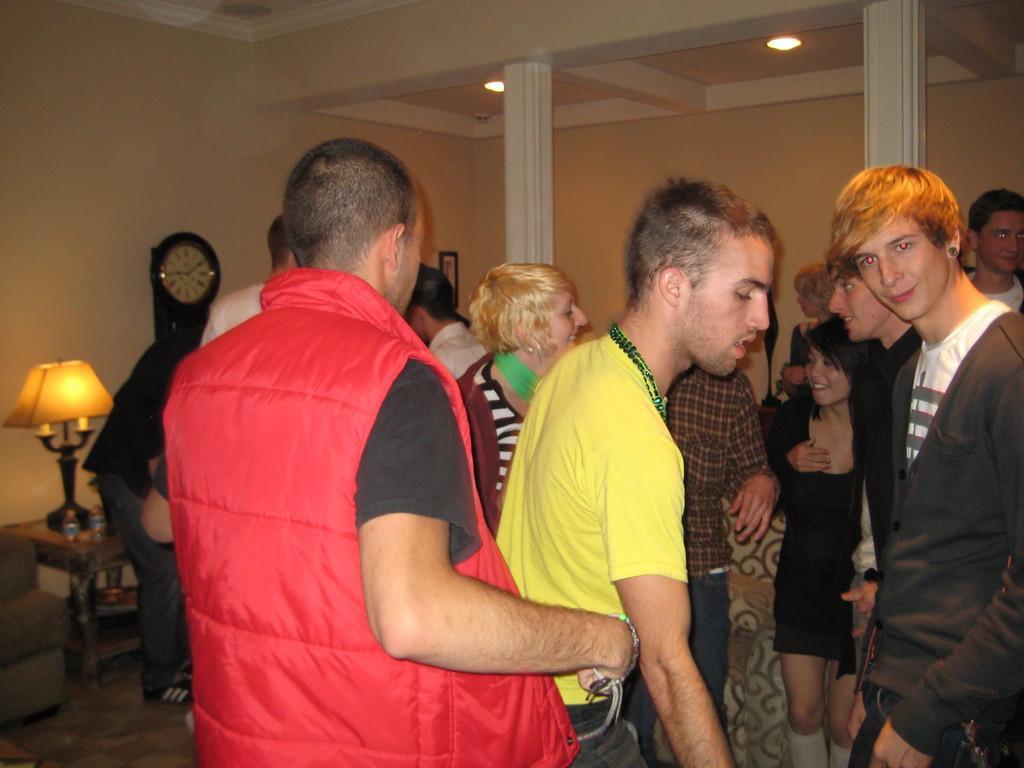How would you summarize this image in a sentence or two? In this image there are group of persons standing, there is a couch towards the left of the image, there is a table, there is an object on the table, there is a lamp on the table, there are pillars, there is the wall, there is a wall clock on the wall, there is a photo frame on the wall, at the top of the image there is the roof, there are lights on the roof. 